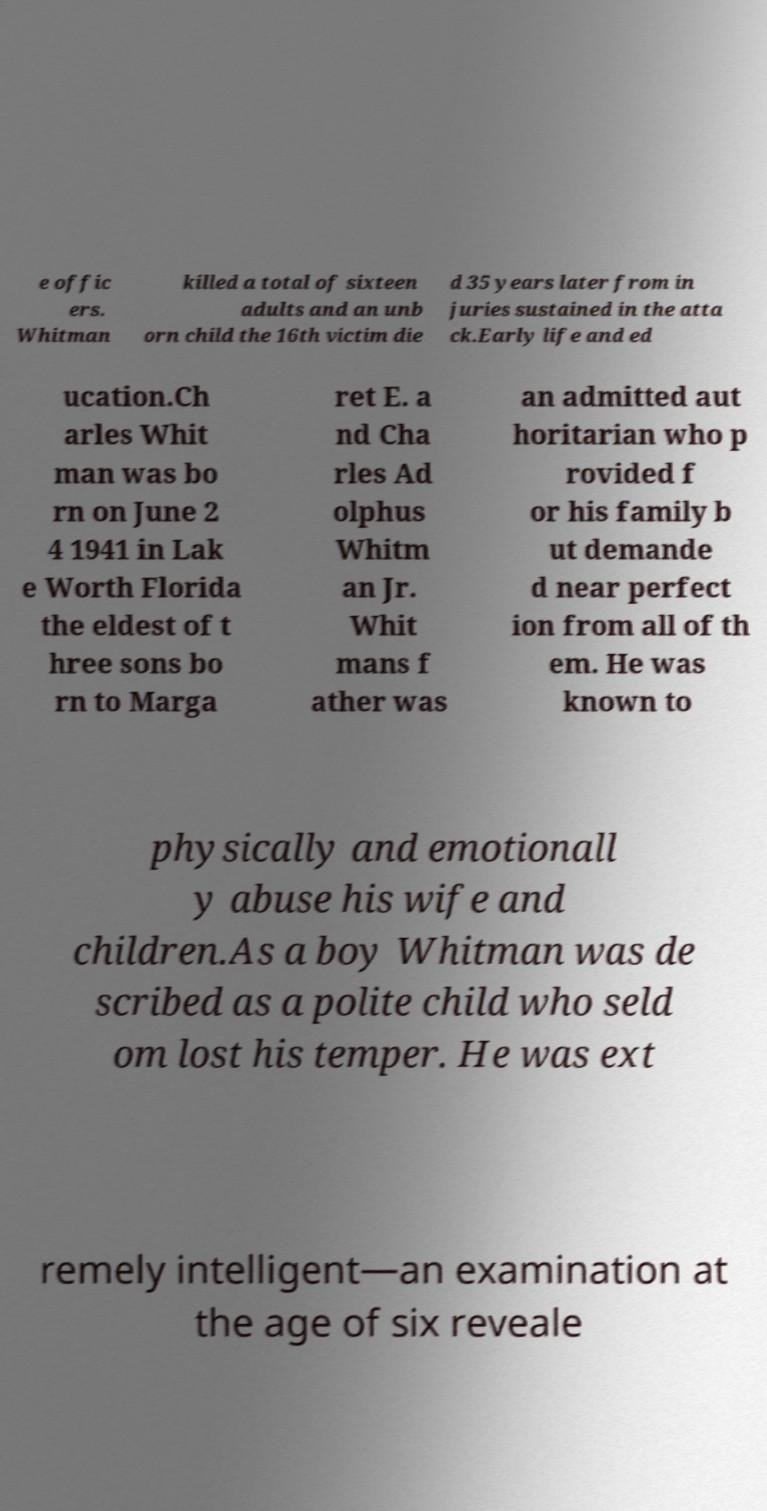Please identify and transcribe the text found in this image. e offic ers. Whitman killed a total of sixteen adults and an unb orn child the 16th victim die d 35 years later from in juries sustained in the atta ck.Early life and ed ucation.Ch arles Whit man was bo rn on June 2 4 1941 in Lak e Worth Florida the eldest of t hree sons bo rn to Marga ret E. a nd Cha rles Ad olphus Whitm an Jr. Whit mans f ather was an admitted aut horitarian who p rovided f or his family b ut demande d near perfect ion from all of th em. He was known to physically and emotionall y abuse his wife and children.As a boy Whitman was de scribed as a polite child who seld om lost his temper. He was ext remely intelligent—an examination at the age of six reveale 